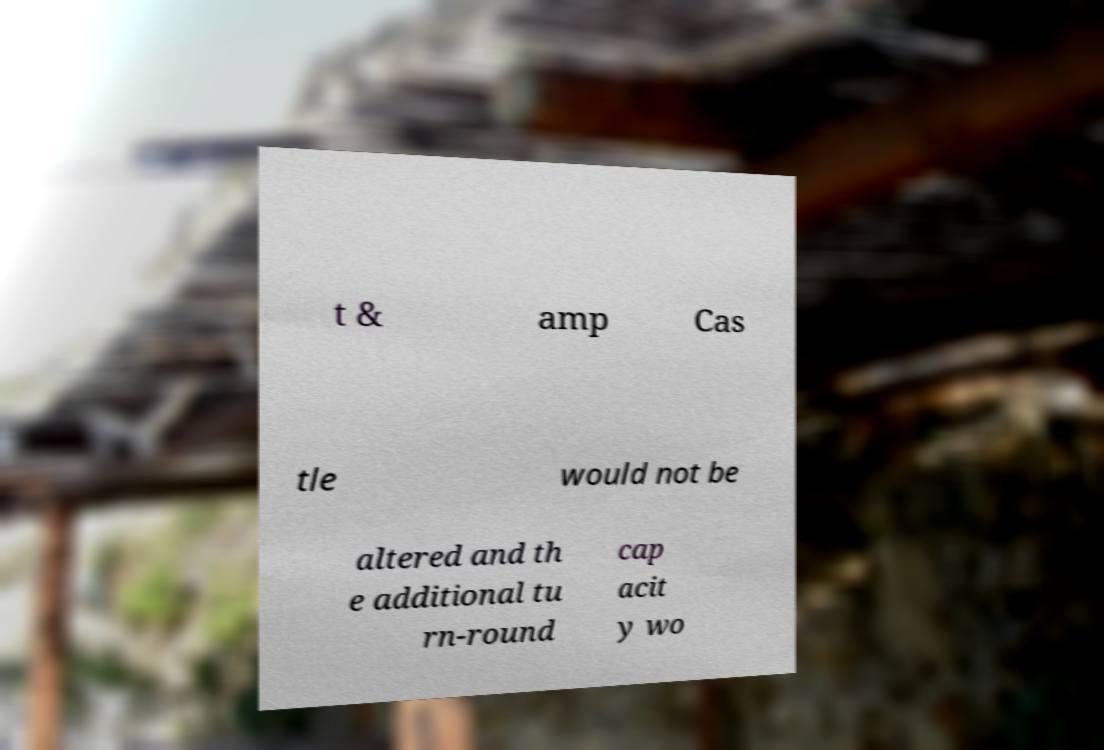Could you extract and type out the text from this image? t & amp Cas tle would not be altered and th e additional tu rn-round cap acit y wo 